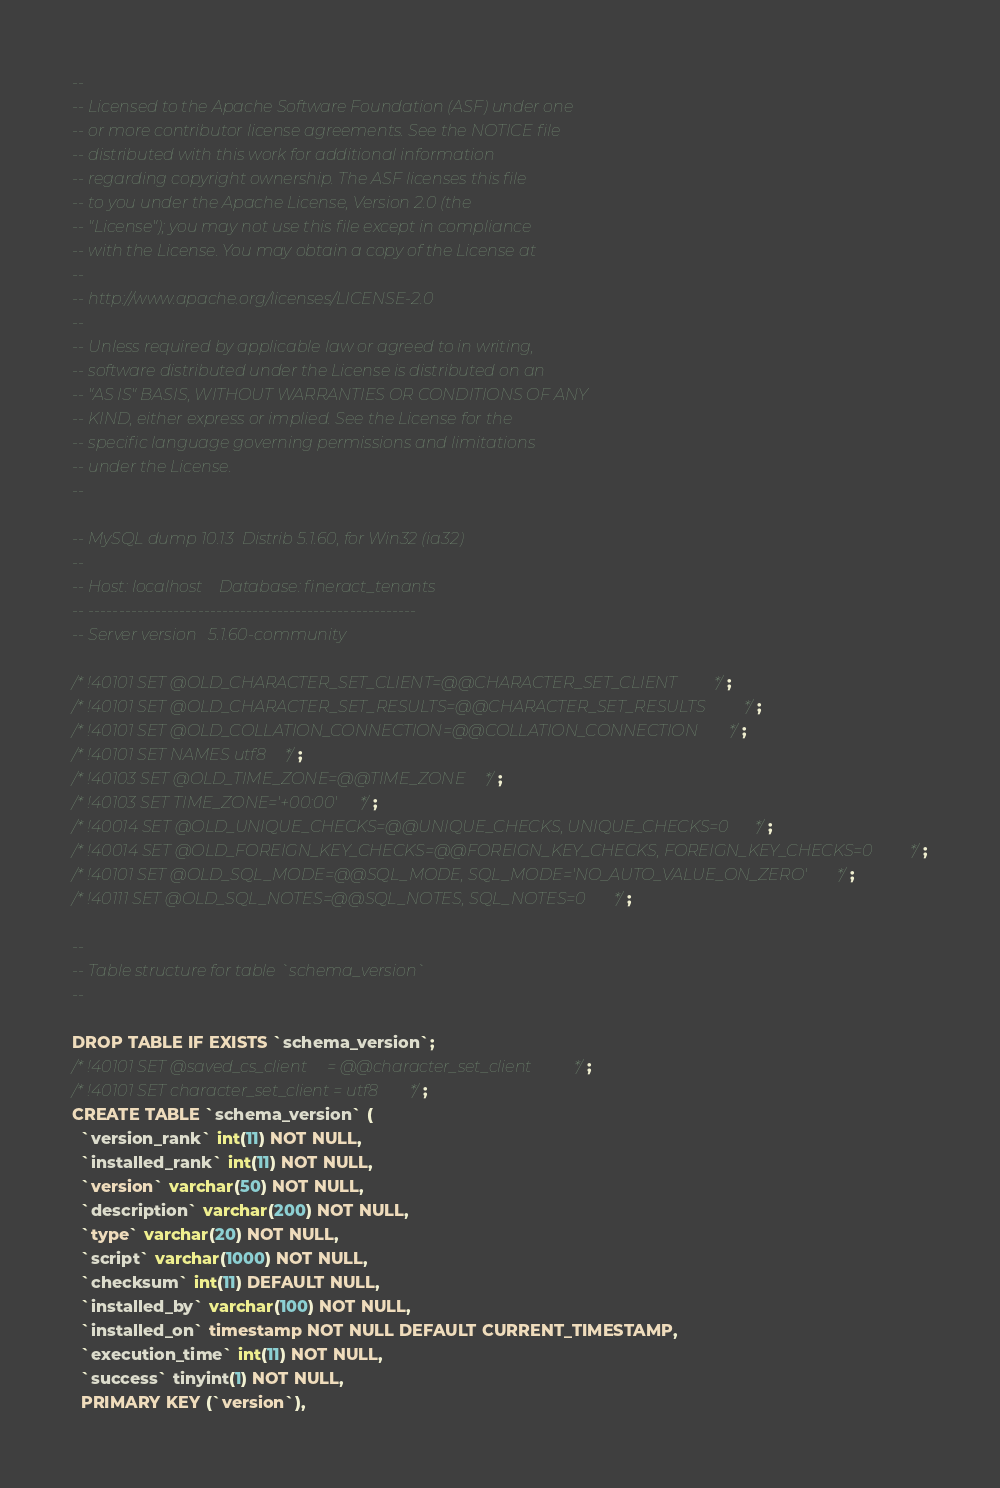<code> <loc_0><loc_0><loc_500><loc_500><_SQL_>--
-- Licensed to the Apache Software Foundation (ASF) under one
-- or more contributor license agreements. See the NOTICE file
-- distributed with this work for additional information
-- regarding copyright ownership. The ASF licenses this file
-- to you under the Apache License, Version 2.0 (the
-- "License"); you may not use this file except in compliance
-- with the License. You may obtain a copy of the License at
--
-- http://www.apache.org/licenses/LICENSE-2.0
--
-- Unless required by applicable law or agreed to in writing,
-- software distributed under the License is distributed on an
-- "AS IS" BASIS, WITHOUT WARRANTIES OR CONDITIONS OF ANY
-- KIND, either express or implied. See the License for the
-- specific language governing permissions and limitations
-- under the License.
--

-- MySQL dump 10.13  Distrib 5.1.60, for Win32 (ia32)
--
-- Host: localhost    Database: fineract_tenants
-- ------------------------------------------------------
-- Server version	5.1.60-community

/*!40101 SET @OLD_CHARACTER_SET_CLIENT=@@CHARACTER_SET_CLIENT */;
/*!40101 SET @OLD_CHARACTER_SET_RESULTS=@@CHARACTER_SET_RESULTS */;
/*!40101 SET @OLD_COLLATION_CONNECTION=@@COLLATION_CONNECTION */;
/*!40101 SET NAMES utf8 */;
/*!40103 SET @OLD_TIME_ZONE=@@TIME_ZONE */;
/*!40103 SET TIME_ZONE='+00:00' */;
/*!40014 SET @OLD_UNIQUE_CHECKS=@@UNIQUE_CHECKS, UNIQUE_CHECKS=0 */;
/*!40014 SET @OLD_FOREIGN_KEY_CHECKS=@@FOREIGN_KEY_CHECKS, FOREIGN_KEY_CHECKS=0 */;
/*!40101 SET @OLD_SQL_MODE=@@SQL_MODE, SQL_MODE='NO_AUTO_VALUE_ON_ZERO' */;
/*!40111 SET @OLD_SQL_NOTES=@@SQL_NOTES, SQL_NOTES=0 */;

--
-- Table structure for table `schema_version`
--

DROP TABLE IF EXISTS `schema_version`;
/*!40101 SET @saved_cs_client     = @@character_set_client */;
/*!40101 SET character_set_client = utf8 */;
CREATE TABLE `schema_version` (
  `version_rank` int(11) NOT NULL,
  `installed_rank` int(11) NOT NULL,
  `version` varchar(50) NOT NULL,
  `description` varchar(200) NOT NULL,
  `type` varchar(20) NOT NULL,
  `script` varchar(1000) NOT NULL,
  `checksum` int(11) DEFAULT NULL,
  `installed_by` varchar(100) NOT NULL,
  `installed_on` timestamp NOT NULL DEFAULT CURRENT_TIMESTAMP,
  `execution_time` int(11) NOT NULL,
  `success` tinyint(1) NOT NULL,
  PRIMARY KEY (`version`),</code> 